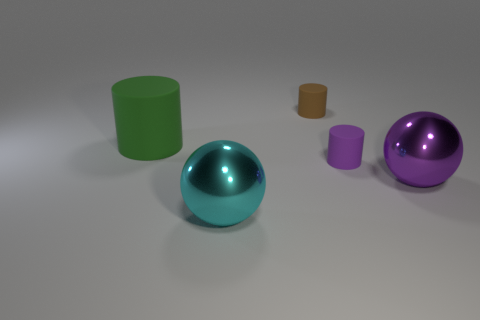Add 4 tiny matte things. How many objects exist? 9 Subtract all balls. How many objects are left? 3 Add 5 large purple metallic balls. How many large purple metallic balls are left? 6 Add 2 tiny purple rubber cylinders. How many tiny purple rubber cylinders exist? 3 Subtract 0 red spheres. How many objects are left? 5 Subtract all large cyan spheres. Subtract all large cyan spheres. How many objects are left? 3 